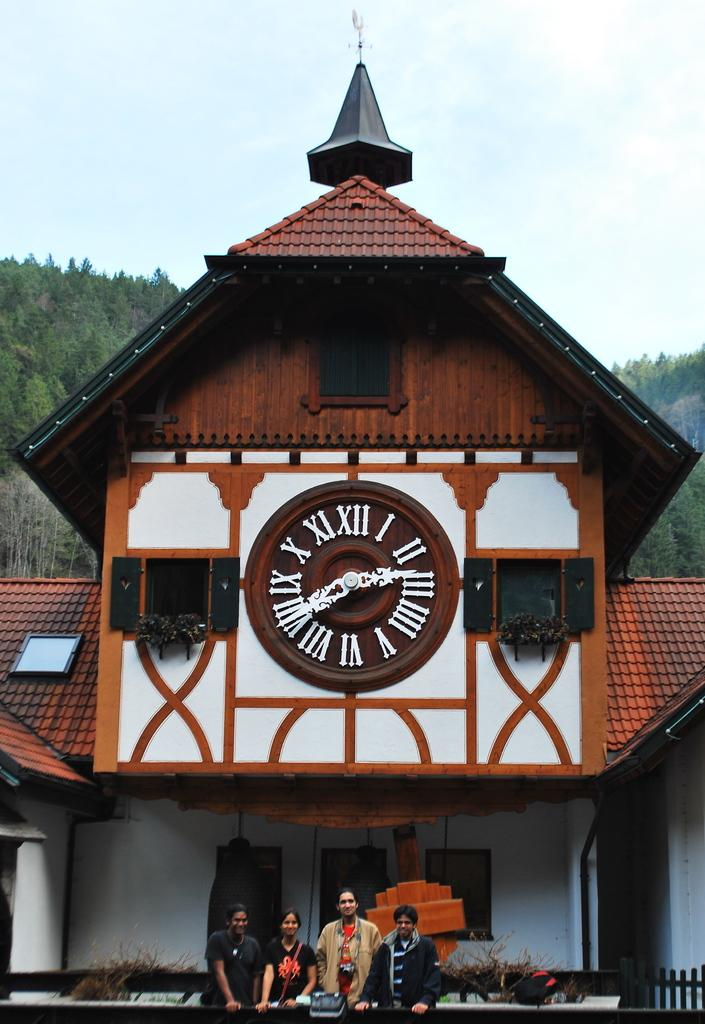<image>
Write a terse but informative summary of the picture. Four people posing in front of a building with a large clock showing the time of 2:40 